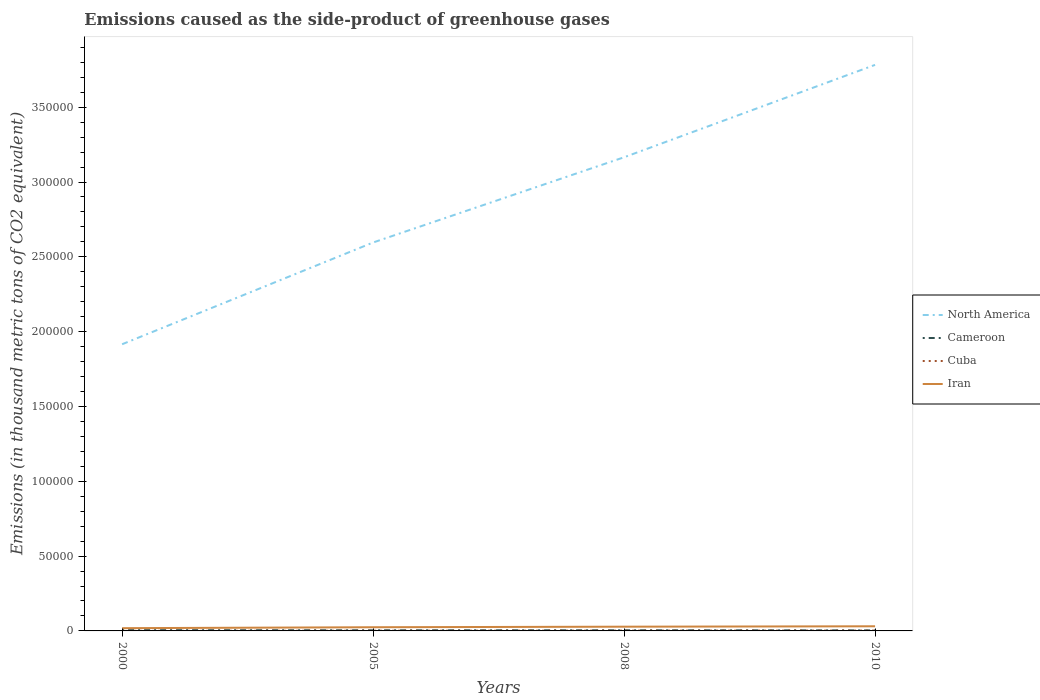Across all years, what is the maximum emissions caused as the side-product of greenhouse gases in North America?
Provide a short and direct response. 1.92e+05. What is the total emissions caused as the side-product of greenhouse gases in Cameroon in the graph?
Provide a short and direct response. 92.6. What is the difference between the highest and the second highest emissions caused as the side-product of greenhouse gases in Cuba?
Offer a very short reply. 191.8. What is the difference between the highest and the lowest emissions caused as the side-product of greenhouse gases in Cuba?
Offer a very short reply. 2. Is the emissions caused as the side-product of greenhouse gases in North America strictly greater than the emissions caused as the side-product of greenhouse gases in Cuba over the years?
Provide a succinct answer. No. How many years are there in the graph?
Provide a short and direct response. 4. What is the difference between two consecutive major ticks on the Y-axis?
Your response must be concise. 5.00e+04. Does the graph contain grids?
Make the answer very short. No. How many legend labels are there?
Make the answer very short. 4. How are the legend labels stacked?
Make the answer very short. Vertical. What is the title of the graph?
Give a very brief answer. Emissions caused as the side-product of greenhouse gases. What is the label or title of the Y-axis?
Make the answer very short. Emissions (in thousand metric tons of CO2 equivalent). What is the Emissions (in thousand metric tons of CO2 equivalent) in North America in 2000?
Ensure brevity in your answer.  1.92e+05. What is the Emissions (in thousand metric tons of CO2 equivalent) of Cameroon in 2000?
Offer a terse response. 514.7. What is the Emissions (in thousand metric tons of CO2 equivalent) in Cuba in 2000?
Ensure brevity in your answer.  34.2. What is the Emissions (in thousand metric tons of CO2 equivalent) of Iran in 2000?
Give a very brief answer. 1833.4. What is the Emissions (in thousand metric tons of CO2 equivalent) in North America in 2005?
Offer a terse response. 2.60e+05. What is the Emissions (in thousand metric tons of CO2 equivalent) of Cameroon in 2005?
Offer a terse response. 417.5. What is the Emissions (in thousand metric tons of CO2 equivalent) in Cuba in 2005?
Make the answer very short. 127.8. What is the Emissions (in thousand metric tons of CO2 equivalent) in Iran in 2005?
Your response must be concise. 2464. What is the Emissions (in thousand metric tons of CO2 equivalent) of North America in 2008?
Offer a very short reply. 3.17e+05. What is the Emissions (in thousand metric tons of CO2 equivalent) of Cameroon in 2008?
Make the answer very short. 422.1. What is the Emissions (in thousand metric tons of CO2 equivalent) in Cuba in 2008?
Provide a succinct answer. 185.9. What is the Emissions (in thousand metric tons of CO2 equivalent) in Iran in 2008?
Your answer should be very brief. 2828.5. What is the Emissions (in thousand metric tons of CO2 equivalent) in North America in 2010?
Your response must be concise. 3.78e+05. What is the Emissions (in thousand metric tons of CO2 equivalent) in Cameroon in 2010?
Ensure brevity in your answer.  353. What is the Emissions (in thousand metric tons of CO2 equivalent) in Cuba in 2010?
Ensure brevity in your answer.  226. What is the Emissions (in thousand metric tons of CO2 equivalent) in Iran in 2010?
Keep it short and to the point. 3097. Across all years, what is the maximum Emissions (in thousand metric tons of CO2 equivalent) of North America?
Your answer should be compact. 3.78e+05. Across all years, what is the maximum Emissions (in thousand metric tons of CO2 equivalent) of Cameroon?
Ensure brevity in your answer.  514.7. Across all years, what is the maximum Emissions (in thousand metric tons of CO2 equivalent) of Cuba?
Provide a succinct answer. 226. Across all years, what is the maximum Emissions (in thousand metric tons of CO2 equivalent) in Iran?
Ensure brevity in your answer.  3097. Across all years, what is the minimum Emissions (in thousand metric tons of CO2 equivalent) of North America?
Provide a short and direct response. 1.92e+05. Across all years, what is the minimum Emissions (in thousand metric tons of CO2 equivalent) of Cameroon?
Give a very brief answer. 353. Across all years, what is the minimum Emissions (in thousand metric tons of CO2 equivalent) of Cuba?
Provide a succinct answer. 34.2. Across all years, what is the minimum Emissions (in thousand metric tons of CO2 equivalent) in Iran?
Make the answer very short. 1833.4. What is the total Emissions (in thousand metric tons of CO2 equivalent) of North America in the graph?
Provide a short and direct response. 1.15e+06. What is the total Emissions (in thousand metric tons of CO2 equivalent) of Cameroon in the graph?
Give a very brief answer. 1707.3. What is the total Emissions (in thousand metric tons of CO2 equivalent) in Cuba in the graph?
Provide a short and direct response. 573.9. What is the total Emissions (in thousand metric tons of CO2 equivalent) in Iran in the graph?
Your answer should be very brief. 1.02e+04. What is the difference between the Emissions (in thousand metric tons of CO2 equivalent) in North America in 2000 and that in 2005?
Keep it short and to the point. -6.80e+04. What is the difference between the Emissions (in thousand metric tons of CO2 equivalent) in Cameroon in 2000 and that in 2005?
Your response must be concise. 97.2. What is the difference between the Emissions (in thousand metric tons of CO2 equivalent) in Cuba in 2000 and that in 2005?
Your answer should be compact. -93.6. What is the difference between the Emissions (in thousand metric tons of CO2 equivalent) of Iran in 2000 and that in 2005?
Make the answer very short. -630.6. What is the difference between the Emissions (in thousand metric tons of CO2 equivalent) in North America in 2000 and that in 2008?
Provide a short and direct response. -1.25e+05. What is the difference between the Emissions (in thousand metric tons of CO2 equivalent) of Cameroon in 2000 and that in 2008?
Offer a terse response. 92.6. What is the difference between the Emissions (in thousand metric tons of CO2 equivalent) in Cuba in 2000 and that in 2008?
Keep it short and to the point. -151.7. What is the difference between the Emissions (in thousand metric tons of CO2 equivalent) in Iran in 2000 and that in 2008?
Give a very brief answer. -995.1. What is the difference between the Emissions (in thousand metric tons of CO2 equivalent) of North America in 2000 and that in 2010?
Your answer should be compact. -1.87e+05. What is the difference between the Emissions (in thousand metric tons of CO2 equivalent) of Cameroon in 2000 and that in 2010?
Keep it short and to the point. 161.7. What is the difference between the Emissions (in thousand metric tons of CO2 equivalent) of Cuba in 2000 and that in 2010?
Your answer should be very brief. -191.8. What is the difference between the Emissions (in thousand metric tons of CO2 equivalent) of Iran in 2000 and that in 2010?
Your answer should be very brief. -1263.6. What is the difference between the Emissions (in thousand metric tons of CO2 equivalent) of North America in 2005 and that in 2008?
Provide a short and direct response. -5.70e+04. What is the difference between the Emissions (in thousand metric tons of CO2 equivalent) of Cuba in 2005 and that in 2008?
Ensure brevity in your answer.  -58.1. What is the difference between the Emissions (in thousand metric tons of CO2 equivalent) of Iran in 2005 and that in 2008?
Your response must be concise. -364.5. What is the difference between the Emissions (in thousand metric tons of CO2 equivalent) of North America in 2005 and that in 2010?
Make the answer very short. -1.19e+05. What is the difference between the Emissions (in thousand metric tons of CO2 equivalent) of Cameroon in 2005 and that in 2010?
Your answer should be compact. 64.5. What is the difference between the Emissions (in thousand metric tons of CO2 equivalent) of Cuba in 2005 and that in 2010?
Give a very brief answer. -98.2. What is the difference between the Emissions (in thousand metric tons of CO2 equivalent) in Iran in 2005 and that in 2010?
Offer a very short reply. -633. What is the difference between the Emissions (in thousand metric tons of CO2 equivalent) of North America in 2008 and that in 2010?
Offer a very short reply. -6.17e+04. What is the difference between the Emissions (in thousand metric tons of CO2 equivalent) of Cameroon in 2008 and that in 2010?
Provide a succinct answer. 69.1. What is the difference between the Emissions (in thousand metric tons of CO2 equivalent) in Cuba in 2008 and that in 2010?
Your answer should be very brief. -40.1. What is the difference between the Emissions (in thousand metric tons of CO2 equivalent) of Iran in 2008 and that in 2010?
Provide a short and direct response. -268.5. What is the difference between the Emissions (in thousand metric tons of CO2 equivalent) of North America in 2000 and the Emissions (in thousand metric tons of CO2 equivalent) of Cameroon in 2005?
Offer a terse response. 1.91e+05. What is the difference between the Emissions (in thousand metric tons of CO2 equivalent) in North America in 2000 and the Emissions (in thousand metric tons of CO2 equivalent) in Cuba in 2005?
Keep it short and to the point. 1.91e+05. What is the difference between the Emissions (in thousand metric tons of CO2 equivalent) of North America in 2000 and the Emissions (in thousand metric tons of CO2 equivalent) of Iran in 2005?
Keep it short and to the point. 1.89e+05. What is the difference between the Emissions (in thousand metric tons of CO2 equivalent) of Cameroon in 2000 and the Emissions (in thousand metric tons of CO2 equivalent) of Cuba in 2005?
Your response must be concise. 386.9. What is the difference between the Emissions (in thousand metric tons of CO2 equivalent) of Cameroon in 2000 and the Emissions (in thousand metric tons of CO2 equivalent) of Iran in 2005?
Make the answer very short. -1949.3. What is the difference between the Emissions (in thousand metric tons of CO2 equivalent) in Cuba in 2000 and the Emissions (in thousand metric tons of CO2 equivalent) in Iran in 2005?
Your response must be concise. -2429.8. What is the difference between the Emissions (in thousand metric tons of CO2 equivalent) of North America in 2000 and the Emissions (in thousand metric tons of CO2 equivalent) of Cameroon in 2008?
Offer a very short reply. 1.91e+05. What is the difference between the Emissions (in thousand metric tons of CO2 equivalent) in North America in 2000 and the Emissions (in thousand metric tons of CO2 equivalent) in Cuba in 2008?
Your response must be concise. 1.91e+05. What is the difference between the Emissions (in thousand metric tons of CO2 equivalent) of North America in 2000 and the Emissions (in thousand metric tons of CO2 equivalent) of Iran in 2008?
Give a very brief answer. 1.89e+05. What is the difference between the Emissions (in thousand metric tons of CO2 equivalent) of Cameroon in 2000 and the Emissions (in thousand metric tons of CO2 equivalent) of Cuba in 2008?
Provide a succinct answer. 328.8. What is the difference between the Emissions (in thousand metric tons of CO2 equivalent) of Cameroon in 2000 and the Emissions (in thousand metric tons of CO2 equivalent) of Iran in 2008?
Provide a succinct answer. -2313.8. What is the difference between the Emissions (in thousand metric tons of CO2 equivalent) in Cuba in 2000 and the Emissions (in thousand metric tons of CO2 equivalent) in Iran in 2008?
Give a very brief answer. -2794.3. What is the difference between the Emissions (in thousand metric tons of CO2 equivalent) of North America in 2000 and the Emissions (in thousand metric tons of CO2 equivalent) of Cameroon in 2010?
Give a very brief answer. 1.91e+05. What is the difference between the Emissions (in thousand metric tons of CO2 equivalent) in North America in 2000 and the Emissions (in thousand metric tons of CO2 equivalent) in Cuba in 2010?
Make the answer very short. 1.91e+05. What is the difference between the Emissions (in thousand metric tons of CO2 equivalent) in North America in 2000 and the Emissions (in thousand metric tons of CO2 equivalent) in Iran in 2010?
Keep it short and to the point. 1.88e+05. What is the difference between the Emissions (in thousand metric tons of CO2 equivalent) in Cameroon in 2000 and the Emissions (in thousand metric tons of CO2 equivalent) in Cuba in 2010?
Ensure brevity in your answer.  288.7. What is the difference between the Emissions (in thousand metric tons of CO2 equivalent) of Cameroon in 2000 and the Emissions (in thousand metric tons of CO2 equivalent) of Iran in 2010?
Make the answer very short. -2582.3. What is the difference between the Emissions (in thousand metric tons of CO2 equivalent) in Cuba in 2000 and the Emissions (in thousand metric tons of CO2 equivalent) in Iran in 2010?
Ensure brevity in your answer.  -3062.8. What is the difference between the Emissions (in thousand metric tons of CO2 equivalent) of North America in 2005 and the Emissions (in thousand metric tons of CO2 equivalent) of Cameroon in 2008?
Make the answer very short. 2.59e+05. What is the difference between the Emissions (in thousand metric tons of CO2 equivalent) of North America in 2005 and the Emissions (in thousand metric tons of CO2 equivalent) of Cuba in 2008?
Offer a terse response. 2.59e+05. What is the difference between the Emissions (in thousand metric tons of CO2 equivalent) in North America in 2005 and the Emissions (in thousand metric tons of CO2 equivalent) in Iran in 2008?
Your answer should be compact. 2.57e+05. What is the difference between the Emissions (in thousand metric tons of CO2 equivalent) of Cameroon in 2005 and the Emissions (in thousand metric tons of CO2 equivalent) of Cuba in 2008?
Your answer should be very brief. 231.6. What is the difference between the Emissions (in thousand metric tons of CO2 equivalent) in Cameroon in 2005 and the Emissions (in thousand metric tons of CO2 equivalent) in Iran in 2008?
Your response must be concise. -2411. What is the difference between the Emissions (in thousand metric tons of CO2 equivalent) in Cuba in 2005 and the Emissions (in thousand metric tons of CO2 equivalent) in Iran in 2008?
Your answer should be very brief. -2700.7. What is the difference between the Emissions (in thousand metric tons of CO2 equivalent) of North America in 2005 and the Emissions (in thousand metric tons of CO2 equivalent) of Cameroon in 2010?
Your response must be concise. 2.59e+05. What is the difference between the Emissions (in thousand metric tons of CO2 equivalent) of North America in 2005 and the Emissions (in thousand metric tons of CO2 equivalent) of Cuba in 2010?
Keep it short and to the point. 2.59e+05. What is the difference between the Emissions (in thousand metric tons of CO2 equivalent) in North America in 2005 and the Emissions (in thousand metric tons of CO2 equivalent) in Iran in 2010?
Provide a short and direct response. 2.56e+05. What is the difference between the Emissions (in thousand metric tons of CO2 equivalent) in Cameroon in 2005 and the Emissions (in thousand metric tons of CO2 equivalent) in Cuba in 2010?
Make the answer very short. 191.5. What is the difference between the Emissions (in thousand metric tons of CO2 equivalent) in Cameroon in 2005 and the Emissions (in thousand metric tons of CO2 equivalent) in Iran in 2010?
Provide a succinct answer. -2679.5. What is the difference between the Emissions (in thousand metric tons of CO2 equivalent) in Cuba in 2005 and the Emissions (in thousand metric tons of CO2 equivalent) in Iran in 2010?
Your answer should be compact. -2969.2. What is the difference between the Emissions (in thousand metric tons of CO2 equivalent) in North America in 2008 and the Emissions (in thousand metric tons of CO2 equivalent) in Cameroon in 2010?
Offer a very short reply. 3.16e+05. What is the difference between the Emissions (in thousand metric tons of CO2 equivalent) of North America in 2008 and the Emissions (in thousand metric tons of CO2 equivalent) of Cuba in 2010?
Keep it short and to the point. 3.16e+05. What is the difference between the Emissions (in thousand metric tons of CO2 equivalent) of North America in 2008 and the Emissions (in thousand metric tons of CO2 equivalent) of Iran in 2010?
Your answer should be compact. 3.13e+05. What is the difference between the Emissions (in thousand metric tons of CO2 equivalent) in Cameroon in 2008 and the Emissions (in thousand metric tons of CO2 equivalent) in Cuba in 2010?
Provide a succinct answer. 196.1. What is the difference between the Emissions (in thousand metric tons of CO2 equivalent) in Cameroon in 2008 and the Emissions (in thousand metric tons of CO2 equivalent) in Iran in 2010?
Offer a terse response. -2674.9. What is the difference between the Emissions (in thousand metric tons of CO2 equivalent) of Cuba in 2008 and the Emissions (in thousand metric tons of CO2 equivalent) of Iran in 2010?
Provide a short and direct response. -2911.1. What is the average Emissions (in thousand metric tons of CO2 equivalent) in North America per year?
Your answer should be very brief. 2.87e+05. What is the average Emissions (in thousand metric tons of CO2 equivalent) of Cameroon per year?
Your answer should be very brief. 426.82. What is the average Emissions (in thousand metric tons of CO2 equivalent) in Cuba per year?
Give a very brief answer. 143.47. What is the average Emissions (in thousand metric tons of CO2 equivalent) in Iran per year?
Give a very brief answer. 2555.72. In the year 2000, what is the difference between the Emissions (in thousand metric tons of CO2 equivalent) in North America and Emissions (in thousand metric tons of CO2 equivalent) in Cameroon?
Your response must be concise. 1.91e+05. In the year 2000, what is the difference between the Emissions (in thousand metric tons of CO2 equivalent) of North America and Emissions (in thousand metric tons of CO2 equivalent) of Cuba?
Your response must be concise. 1.92e+05. In the year 2000, what is the difference between the Emissions (in thousand metric tons of CO2 equivalent) in North America and Emissions (in thousand metric tons of CO2 equivalent) in Iran?
Ensure brevity in your answer.  1.90e+05. In the year 2000, what is the difference between the Emissions (in thousand metric tons of CO2 equivalent) in Cameroon and Emissions (in thousand metric tons of CO2 equivalent) in Cuba?
Give a very brief answer. 480.5. In the year 2000, what is the difference between the Emissions (in thousand metric tons of CO2 equivalent) in Cameroon and Emissions (in thousand metric tons of CO2 equivalent) in Iran?
Your response must be concise. -1318.7. In the year 2000, what is the difference between the Emissions (in thousand metric tons of CO2 equivalent) of Cuba and Emissions (in thousand metric tons of CO2 equivalent) of Iran?
Offer a terse response. -1799.2. In the year 2005, what is the difference between the Emissions (in thousand metric tons of CO2 equivalent) in North America and Emissions (in thousand metric tons of CO2 equivalent) in Cameroon?
Offer a terse response. 2.59e+05. In the year 2005, what is the difference between the Emissions (in thousand metric tons of CO2 equivalent) of North America and Emissions (in thousand metric tons of CO2 equivalent) of Cuba?
Make the answer very short. 2.59e+05. In the year 2005, what is the difference between the Emissions (in thousand metric tons of CO2 equivalent) in North America and Emissions (in thousand metric tons of CO2 equivalent) in Iran?
Keep it short and to the point. 2.57e+05. In the year 2005, what is the difference between the Emissions (in thousand metric tons of CO2 equivalent) in Cameroon and Emissions (in thousand metric tons of CO2 equivalent) in Cuba?
Give a very brief answer. 289.7. In the year 2005, what is the difference between the Emissions (in thousand metric tons of CO2 equivalent) of Cameroon and Emissions (in thousand metric tons of CO2 equivalent) of Iran?
Offer a very short reply. -2046.5. In the year 2005, what is the difference between the Emissions (in thousand metric tons of CO2 equivalent) of Cuba and Emissions (in thousand metric tons of CO2 equivalent) of Iran?
Keep it short and to the point. -2336.2. In the year 2008, what is the difference between the Emissions (in thousand metric tons of CO2 equivalent) in North America and Emissions (in thousand metric tons of CO2 equivalent) in Cameroon?
Offer a very short reply. 3.16e+05. In the year 2008, what is the difference between the Emissions (in thousand metric tons of CO2 equivalent) of North America and Emissions (in thousand metric tons of CO2 equivalent) of Cuba?
Make the answer very short. 3.16e+05. In the year 2008, what is the difference between the Emissions (in thousand metric tons of CO2 equivalent) of North America and Emissions (in thousand metric tons of CO2 equivalent) of Iran?
Offer a terse response. 3.14e+05. In the year 2008, what is the difference between the Emissions (in thousand metric tons of CO2 equivalent) in Cameroon and Emissions (in thousand metric tons of CO2 equivalent) in Cuba?
Make the answer very short. 236.2. In the year 2008, what is the difference between the Emissions (in thousand metric tons of CO2 equivalent) in Cameroon and Emissions (in thousand metric tons of CO2 equivalent) in Iran?
Ensure brevity in your answer.  -2406.4. In the year 2008, what is the difference between the Emissions (in thousand metric tons of CO2 equivalent) in Cuba and Emissions (in thousand metric tons of CO2 equivalent) in Iran?
Make the answer very short. -2642.6. In the year 2010, what is the difference between the Emissions (in thousand metric tons of CO2 equivalent) of North America and Emissions (in thousand metric tons of CO2 equivalent) of Cameroon?
Provide a succinct answer. 3.78e+05. In the year 2010, what is the difference between the Emissions (in thousand metric tons of CO2 equivalent) in North America and Emissions (in thousand metric tons of CO2 equivalent) in Cuba?
Provide a short and direct response. 3.78e+05. In the year 2010, what is the difference between the Emissions (in thousand metric tons of CO2 equivalent) in North America and Emissions (in thousand metric tons of CO2 equivalent) in Iran?
Give a very brief answer. 3.75e+05. In the year 2010, what is the difference between the Emissions (in thousand metric tons of CO2 equivalent) of Cameroon and Emissions (in thousand metric tons of CO2 equivalent) of Cuba?
Provide a short and direct response. 127. In the year 2010, what is the difference between the Emissions (in thousand metric tons of CO2 equivalent) in Cameroon and Emissions (in thousand metric tons of CO2 equivalent) in Iran?
Keep it short and to the point. -2744. In the year 2010, what is the difference between the Emissions (in thousand metric tons of CO2 equivalent) in Cuba and Emissions (in thousand metric tons of CO2 equivalent) in Iran?
Give a very brief answer. -2871. What is the ratio of the Emissions (in thousand metric tons of CO2 equivalent) of North America in 2000 to that in 2005?
Your answer should be very brief. 0.74. What is the ratio of the Emissions (in thousand metric tons of CO2 equivalent) in Cameroon in 2000 to that in 2005?
Your answer should be very brief. 1.23. What is the ratio of the Emissions (in thousand metric tons of CO2 equivalent) of Cuba in 2000 to that in 2005?
Offer a terse response. 0.27. What is the ratio of the Emissions (in thousand metric tons of CO2 equivalent) of Iran in 2000 to that in 2005?
Provide a succinct answer. 0.74. What is the ratio of the Emissions (in thousand metric tons of CO2 equivalent) in North America in 2000 to that in 2008?
Offer a terse response. 0.61. What is the ratio of the Emissions (in thousand metric tons of CO2 equivalent) in Cameroon in 2000 to that in 2008?
Give a very brief answer. 1.22. What is the ratio of the Emissions (in thousand metric tons of CO2 equivalent) of Cuba in 2000 to that in 2008?
Provide a succinct answer. 0.18. What is the ratio of the Emissions (in thousand metric tons of CO2 equivalent) of Iran in 2000 to that in 2008?
Ensure brevity in your answer.  0.65. What is the ratio of the Emissions (in thousand metric tons of CO2 equivalent) of North America in 2000 to that in 2010?
Your response must be concise. 0.51. What is the ratio of the Emissions (in thousand metric tons of CO2 equivalent) of Cameroon in 2000 to that in 2010?
Your response must be concise. 1.46. What is the ratio of the Emissions (in thousand metric tons of CO2 equivalent) in Cuba in 2000 to that in 2010?
Provide a succinct answer. 0.15. What is the ratio of the Emissions (in thousand metric tons of CO2 equivalent) of Iran in 2000 to that in 2010?
Your answer should be very brief. 0.59. What is the ratio of the Emissions (in thousand metric tons of CO2 equivalent) in North America in 2005 to that in 2008?
Your response must be concise. 0.82. What is the ratio of the Emissions (in thousand metric tons of CO2 equivalent) of Cuba in 2005 to that in 2008?
Provide a succinct answer. 0.69. What is the ratio of the Emissions (in thousand metric tons of CO2 equivalent) in Iran in 2005 to that in 2008?
Keep it short and to the point. 0.87. What is the ratio of the Emissions (in thousand metric tons of CO2 equivalent) in North America in 2005 to that in 2010?
Provide a succinct answer. 0.69. What is the ratio of the Emissions (in thousand metric tons of CO2 equivalent) in Cameroon in 2005 to that in 2010?
Provide a short and direct response. 1.18. What is the ratio of the Emissions (in thousand metric tons of CO2 equivalent) of Cuba in 2005 to that in 2010?
Your answer should be compact. 0.57. What is the ratio of the Emissions (in thousand metric tons of CO2 equivalent) of Iran in 2005 to that in 2010?
Ensure brevity in your answer.  0.8. What is the ratio of the Emissions (in thousand metric tons of CO2 equivalent) in North America in 2008 to that in 2010?
Offer a terse response. 0.84. What is the ratio of the Emissions (in thousand metric tons of CO2 equivalent) of Cameroon in 2008 to that in 2010?
Offer a very short reply. 1.2. What is the ratio of the Emissions (in thousand metric tons of CO2 equivalent) in Cuba in 2008 to that in 2010?
Offer a terse response. 0.82. What is the ratio of the Emissions (in thousand metric tons of CO2 equivalent) in Iran in 2008 to that in 2010?
Your answer should be compact. 0.91. What is the difference between the highest and the second highest Emissions (in thousand metric tons of CO2 equivalent) in North America?
Keep it short and to the point. 6.17e+04. What is the difference between the highest and the second highest Emissions (in thousand metric tons of CO2 equivalent) of Cameroon?
Make the answer very short. 92.6. What is the difference between the highest and the second highest Emissions (in thousand metric tons of CO2 equivalent) in Cuba?
Offer a very short reply. 40.1. What is the difference between the highest and the second highest Emissions (in thousand metric tons of CO2 equivalent) in Iran?
Offer a very short reply. 268.5. What is the difference between the highest and the lowest Emissions (in thousand metric tons of CO2 equivalent) of North America?
Give a very brief answer. 1.87e+05. What is the difference between the highest and the lowest Emissions (in thousand metric tons of CO2 equivalent) in Cameroon?
Offer a very short reply. 161.7. What is the difference between the highest and the lowest Emissions (in thousand metric tons of CO2 equivalent) in Cuba?
Your answer should be compact. 191.8. What is the difference between the highest and the lowest Emissions (in thousand metric tons of CO2 equivalent) of Iran?
Keep it short and to the point. 1263.6. 